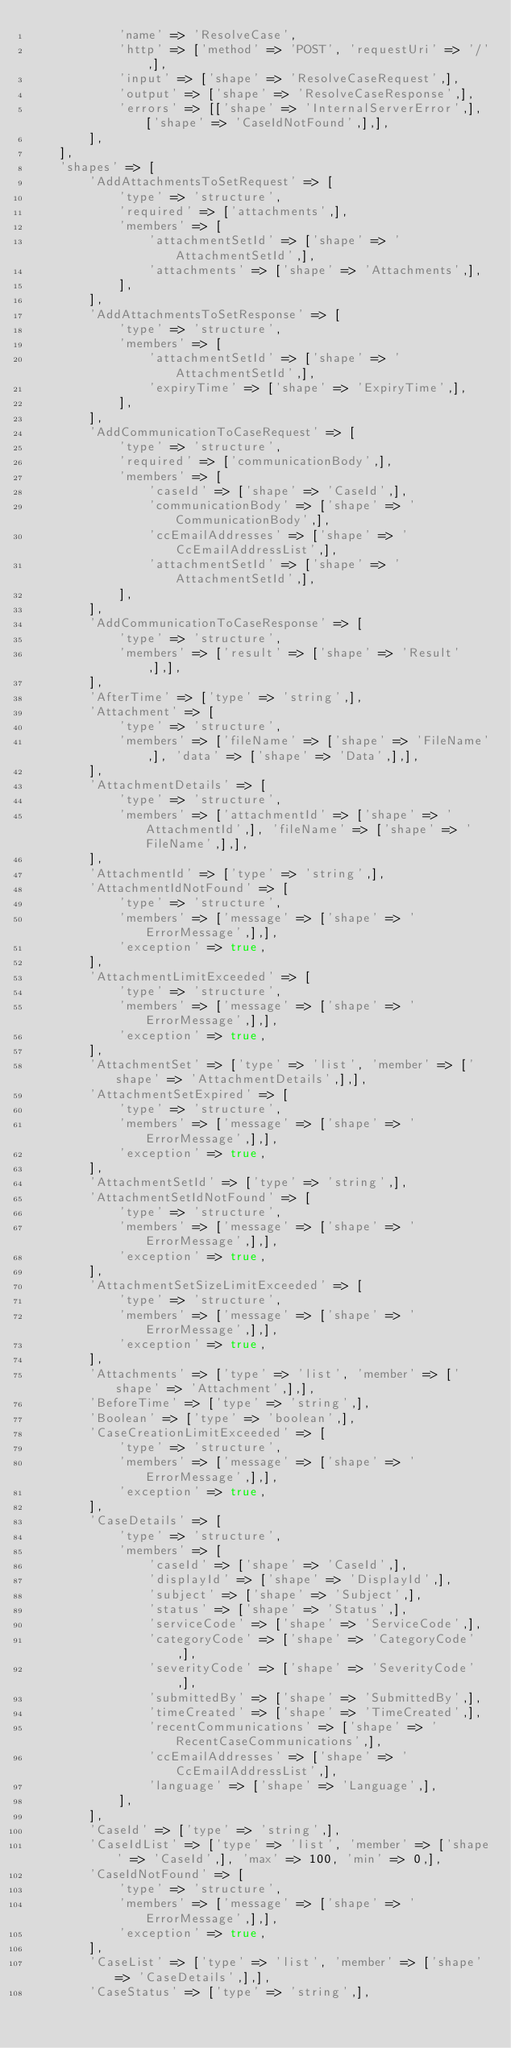Convert code to text. <code><loc_0><loc_0><loc_500><loc_500><_PHP_>            'name' => 'ResolveCase',
            'http' => ['method' => 'POST', 'requestUri' => '/',],
            'input' => ['shape' => 'ResolveCaseRequest',],
            'output' => ['shape' => 'ResolveCaseResponse',],
            'errors' => [['shape' => 'InternalServerError',], ['shape' => 'CaseIdNotFound',],],
        ],
    ],
    'shapes' => [
        'AddAttachmentsToSetRequest' => [
            'type' => 'structure',
            'required' => ['attachments',],
            'members' => [
                'attachmentSetId' => ['shape' => 'AttachmentSetId',],
                'attachments' => ['shape' => 'Attachments',],
            ],
        ],
        'AddAttachmentsToSetResponse' => [
            'type' => 'structure',
            'members' => [
                'attachmentSetId' => ['shape' => 'AttachmentSetId',],
                'expiryTime' => ['shape' => 'ExpiryTime',],
            ],
        ],
        'AddCommunicationToCaseRequest' => [
            'type' => 'structure',
            'required' => ['communicationBody',],
            'members' => [
                'caseId' => ['shape' => 'CaseId',],
                'communicationBody' => ['shape' => 'CommunicationBody',],
                'ccEmailAddresses' => ['shape' => 'CcEmailAddressList',],
                'attachmentSetId' => ['shape' => 'AttachmentSetId',],
            ],
        ],
        'AddCommunicationToCaseResponse' => [
            'type' => 'structure',
            'members' => ['result' => ['shape' => 'Result',],],
        ],
        'AfterTime' => ['type' => 'string',],
        'Attachment' => [
            'type' => 'structure',
            'members' => ['fileName' => ['shape' => 'FileName',], 'data' => ['shape' => 'Data',],],
        ],
        'AttachmentDetails' => [
            'type' => 'structure',
            'members' => ['attachmentId' => ['shape' => 'AttachmentId',], 'fileName' => ['shape' => 'FileName',],],
        ],
        'AttachmentId' => ['type' => 'string',],
        'AttachmentIdNotFound' => [
            'type' => 'structure',
            'members' => ['message' => ['shape' => 'ErrorMessage',],],
            'exception' => true,
        ],
        'AttachmentLimitExceeded' => [
            'type' => 'structure',
            'members' => ['message' => ['shape' => 'ErrorMessage',],],
            'exception' => true,
        ],
        'AttachmentSet' => ['type' => 'list', 'member' => ['shape' => 'AttachmentDetails',],],
        'AttachmentSetExpired' => [
            'type' => 'structure',
            'members' => ['message' => ['shape' => 'ErrorMessage',],],
            'exception' => true,
        ],
        'AttachmentSetId' => ['type' => 'string',],
        'AttachmentSetIdNotFound' => [
            'type' => 'structure',
            'members' => ['message' => ['shape' => 'ErrorMessage',],],
            'exception' => true,
        ],
        'AttachmentSetSizeLimitExceeded' => [
            'type' => 'structure',
            'members' => ['message' => ['shape' => 'ErrorMessage',],],
            'exception' => true,
        ],
        'Attachments' => ['type' => 'list', 'member' => ['shape' => 'Attachment',],],
        'BeforeTime' => ['type' => 'string',],
        'Boolean' => ['type' => 'boolean',],
        'CaseCreationLimitExceeded' => [
            'type' => 'structure',
            'members' => ['message' => ['shape' => 'ErrorMessage',],],
            'exception' => true,
        ],
        'CaseDetails' => [
            'type' => 'structure',
            'members' => [
                'caseId' => ['shape' => 'CaseId',],
                'displayId' => ['shape' => 'DisplayId',],
                'subject' => ['shape' => 'Subject',],
                'status' => ['shape' => 'Status',],
                'serviceCode' => ['shape' => 'ServiceCode',],
                'categoryCode' => ['shape' => 'CategoryCode',],
                'severityCode' => ['shape' => 'SeverityCode',],
                'submittedBy' => ['shape' => 'SubmittedBy',],
                'timeCreated' => ['shape' => 'TimeCreated',],
                'recentCommunications' => ['shape' => 'RecentCaseCommunications',],
                'ccEmailAddresses' => ['shape' => 'CcEmailAddressList',],
                'language' => ['shape' => 'Language',],
            ],
        ],
        'CaseId' => ['type' => 'string',],
        'CaseIdList' => ['type' => 'list', 'member' => ['shape' => 'CaseId',], 'max' => 100, 'min' => 0,],
        'CaseIdNotFound' => [
            'type' => 'structure',
            'members' => ['message' => ['shape' => 'ErrorMessage',],],
            'exception' => true,
        ],
        'CaseList' => ['type' => 'list', 'member' => ['shape' => 'CaseDetails',],],
        'CaseStatus' => ['type' => 'string',],</code> 